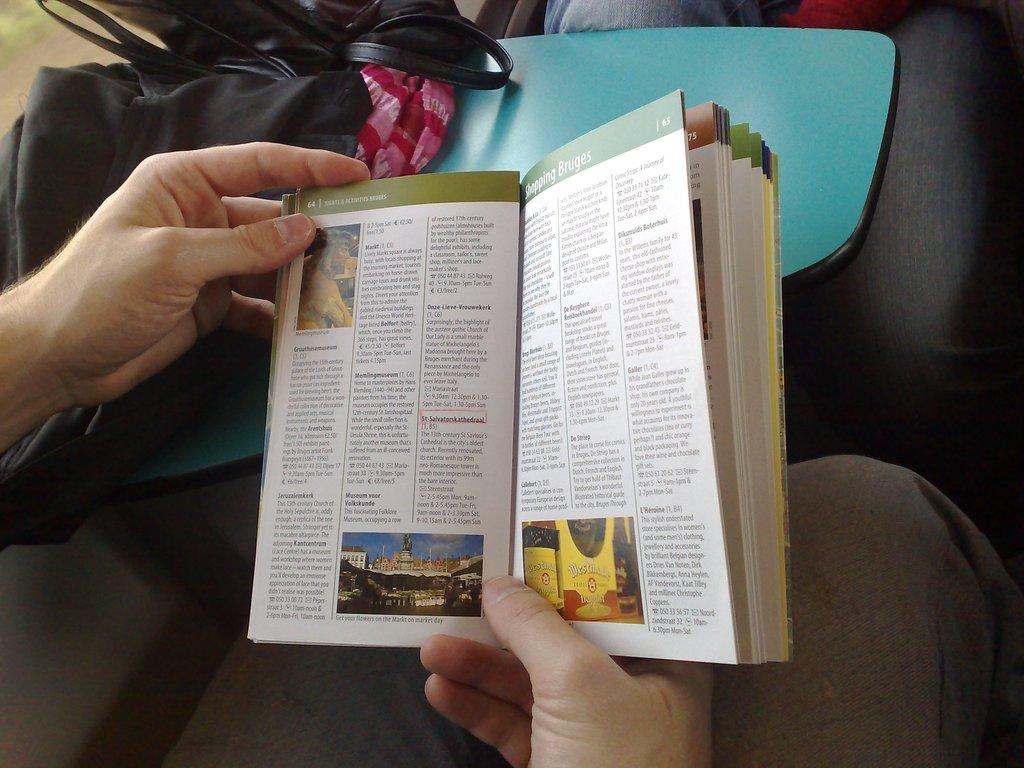<image>
Provide a brief description of the given image. Hands holding a book with the headline on top saying Shopping Bruges. 